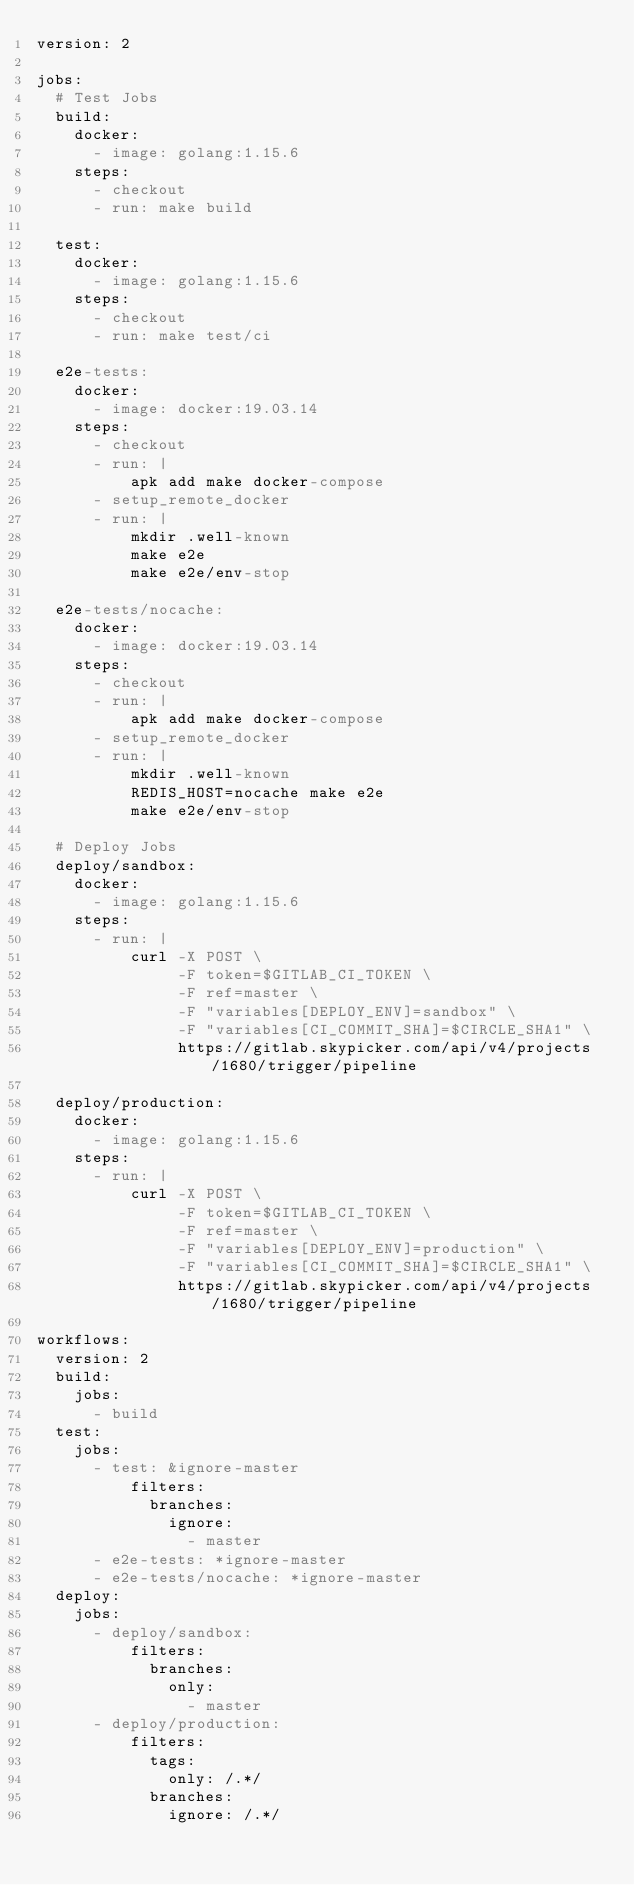<code> <loc_0><loc_0><loc_500><loc_500><_YAML_>version: 2

jobs:
  # Test Jobs
  build:
    docker:
      - image: golang:1.15.6
    steps:
      - checkout
      - run: make build

  test:
    docker:
      - image: golang:1.15.6
    steps:
      - checkout
      - run: make test/ci

  e2e-tests:
    docker:
      - image: docker:19.03.14
    steps:
      - checkout
      - run: |
          apk add make docker-compose
      - setup_remote_docker
      - run: |
          mkdir .well-known
          make e2e
          make e2e/env-stop

  e2e-tests/nocache:
    docker:
      - image: docker:19.03.14
    steps:
      - checkout
      - run: |
          apk add make docker-compose
      - setup_remote_docker
      - run: |
          mkdir .well-known
          REDIS_HOST=nocache make e2e
          make e2e/env-stop

  # Deploy Jobs
  deploy/sandbox:
    docker:
      - image: golang:1.15.6
    steps:
      - run: |
          curl -X POST \
               -F token=$GITLAB_CI_TOKEN \
               -F ref=master \
               -F "variables[DEPLOY_ENV]=sandbox" \
               -F "variables[CI_COMMIT_SHA]=$CIRCLE_SHA1" \
               https://gitlab.skypicker.com/api/v4/projects/1680/trigger/pipeline

  deploy/production:
    docker:
      - image: golang:1.15.6
    steps:
      - run: |
          curl -X POST \
               -F token=$GITLAB_CI_TOKEN \
               -F ref=master \
               -F "variables[DEPLOY_ENV]=production" \
               -F "variables[CI_COMMIT_SHA]=$CIRCLE_SHA1" \
               https://gitlab.skypicker.com/api/v4/projects/1680/trigger/pipeline

workflows:
  version: 2
  build:
    jobs:
      - build
  test:
    jobs:
      - test: &ignore-master
          filters:
            branches:
              ignore:
                - master
      - e2e-tests: *ignore-master
      - e2e-tests/nocache: *ignore-master
  deploy:
    jobs:
      - deploy/sandbox:
          filters:
            branches:
              only:
                - master
      - deploy/production:
          filters:
            tags:
              only: /.*/
            branches:
              ignore: /.*/
</code> 